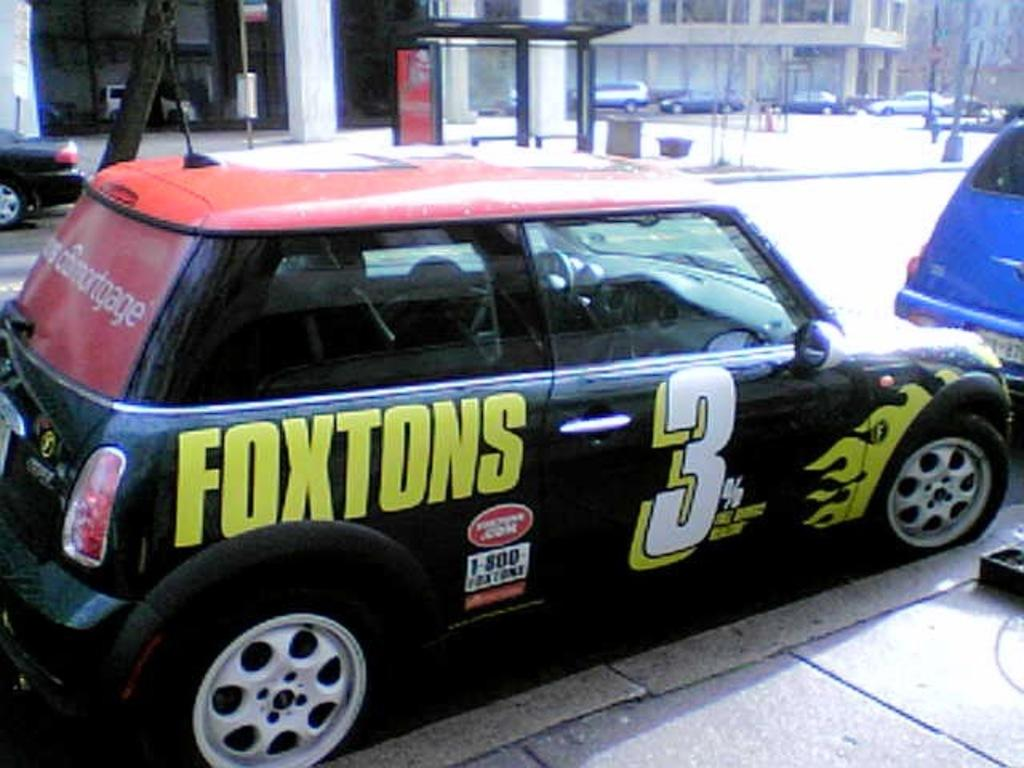What is happening on the road in the image? There are vehicles on the road in the image. What can be seen in the distance behind the vehicles? There are buildings visible in the background of the image. Where is the pan being used in the image? There is no pan present in the image. Can you see the aunt in the image? There is no aunt present in the image. 